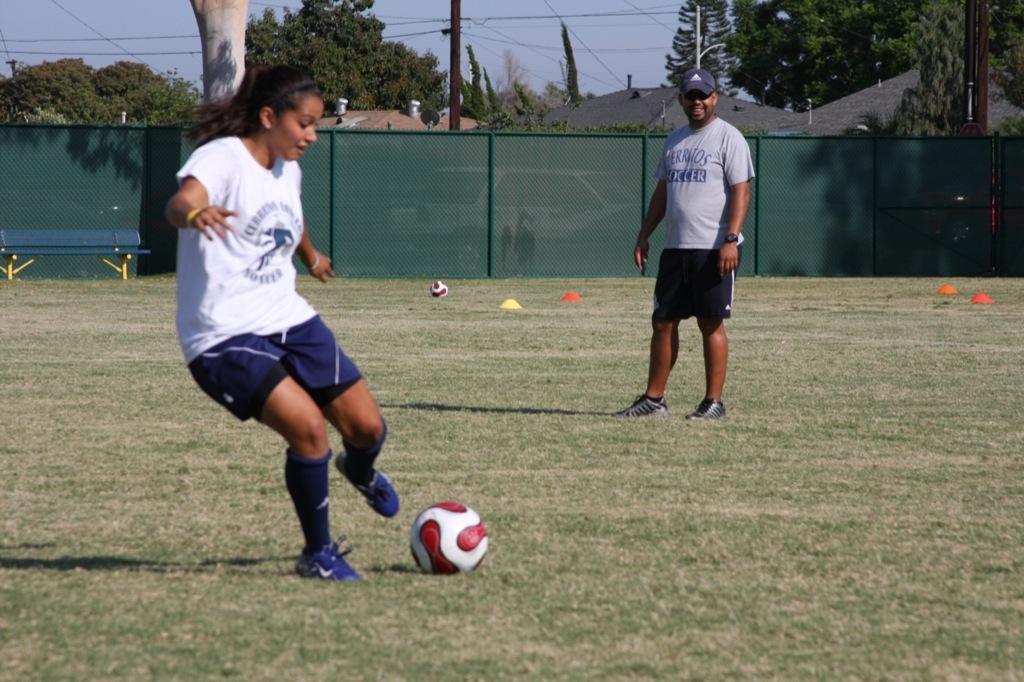Please provide a concise description of this image. This picture might be taken inside a playground. In this image, on the left side, we can see a woman playing a football. On the right side, we can see a man standing. In the background, we can see a net fence, trees, houses, electrical wires. On the top, we can see a sky, at the bottom, we can see football and a grass. 